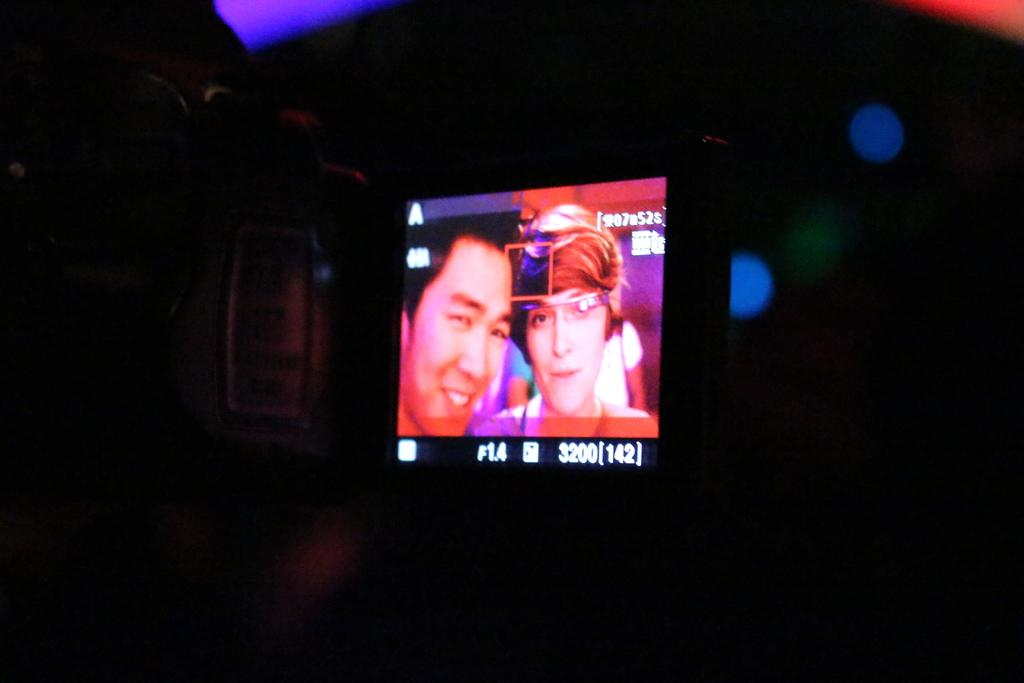What is the main subject of the image? The main subject of the image is a camera screen. What can be seen on the camera screen? People are visible on the camera screen. How would you describe the background of the camera screen? The background of the camera screen is dark. How many spiders can be seen crawling on the train in the image? There is no train or spiders present in the image; it features a camera screen with people and a dark background. 